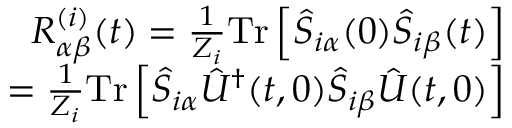Convert formula to latex. <formula><loc_0><loc_0><loc_500><loc_500>\begin{array} { r } { R _ { \alpha \beta } ^ { ( i ) } ( t ) = \frac { 1 } { Z _ { i } } T r \left [ \hat { S } _ { i \alpha } ( 0 ) \hat { S } _ { i \beta } ( t ) \right ] } \\ { = \frac { 1 } { Z _ { i } } T r \left [ \hat { S } _ { i \alpha } \hat { U } ^ { \dagger } ( t , 0 ) \hat { S } _ { i \beta } \hat { U } ( t , 0 ) \right ] } \end{array}</formula> 